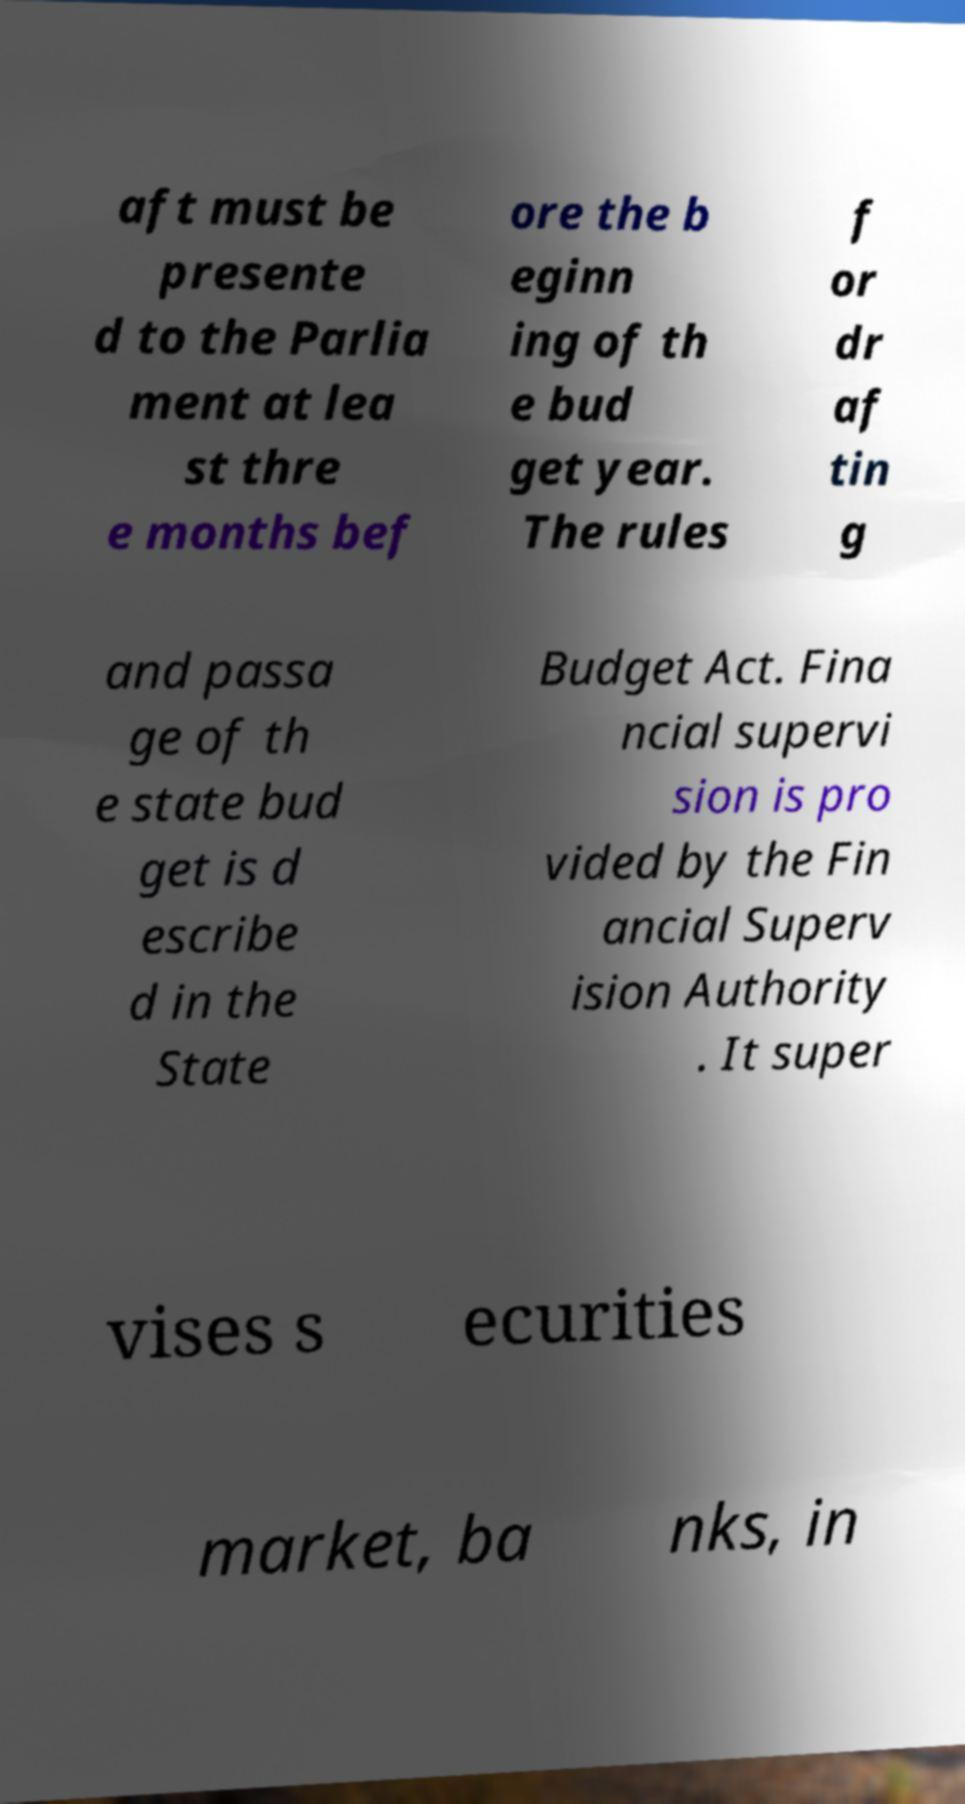Please identify and transcribe the text found in this image. aft must be presente d to the Parlia ment at lea st thre e months bef ore the b eginn ing of th e bud get year. The rules f or dr af tin g and passa ge of th e state bud get is d escribe d in the State Budget Act. Fina ncial supervi sion is pro vided by the Fin ancial Superv ision Authority . It super vises s ecurities market, ba nks, in 